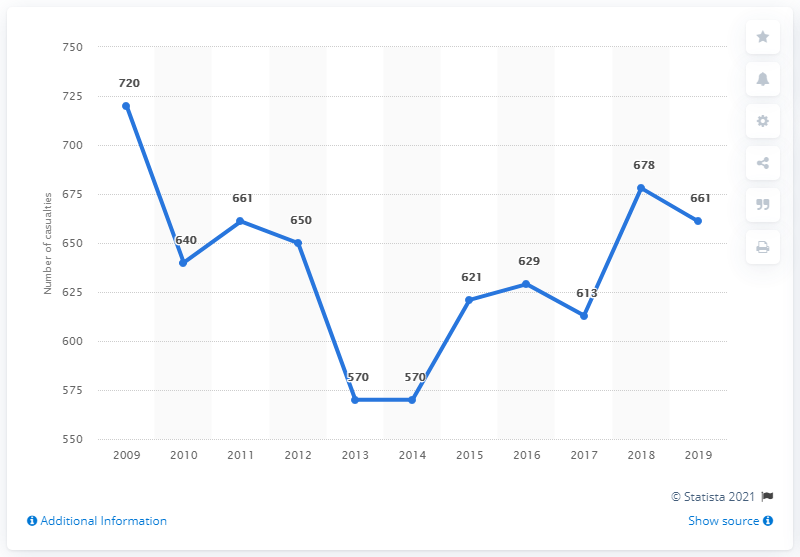Mention a couple of crucial points in this snapshot. In 2019, 661 people lost their lives in traffic-related accidents in the Netherlands. 